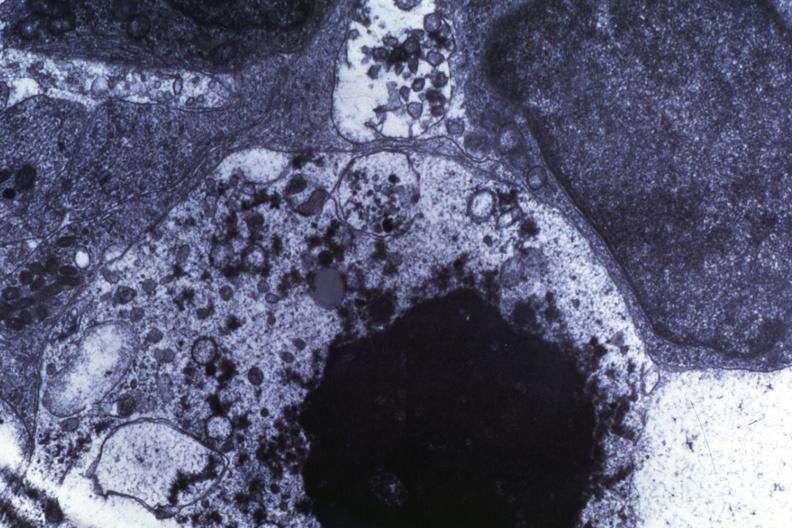s chest and abdomen slide present?
Answer the question using a single word or phrase. No 